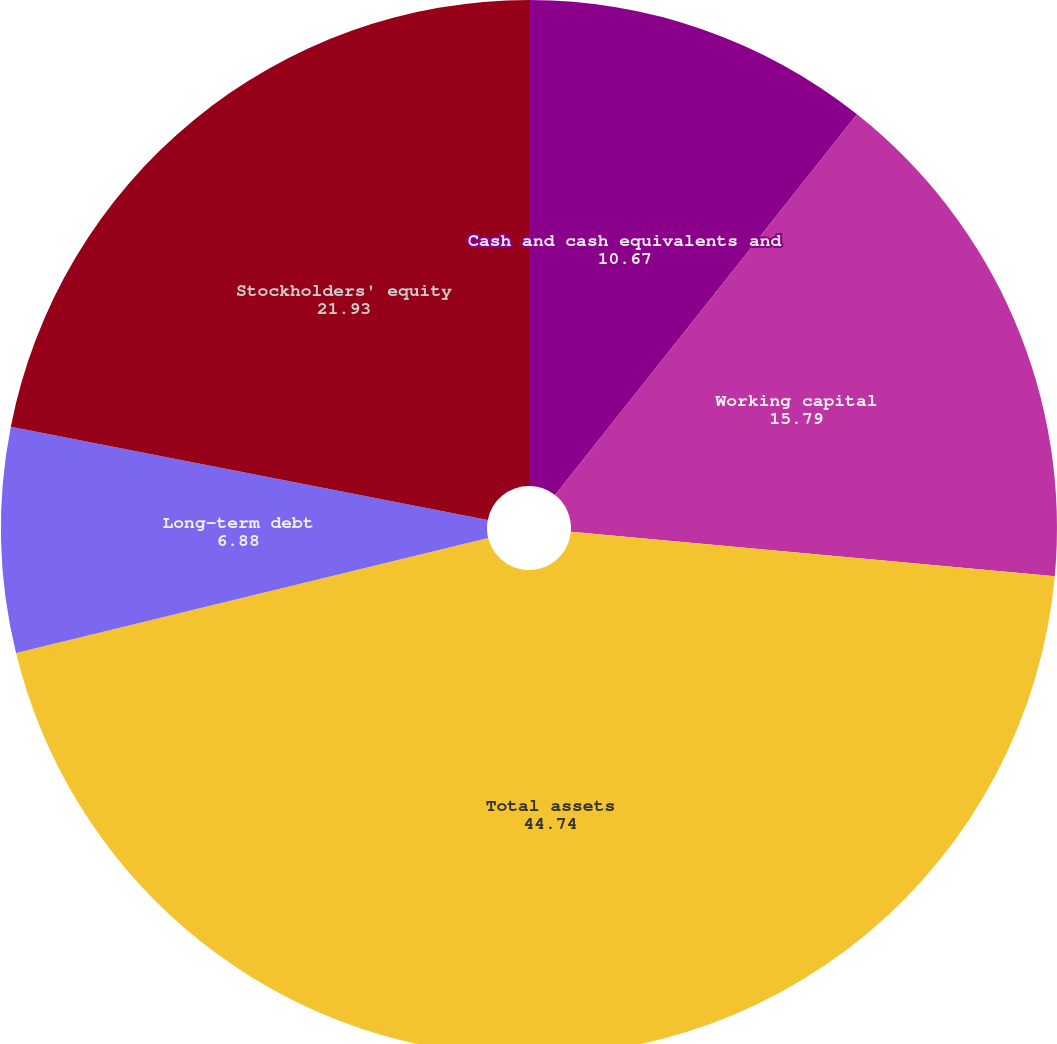<chart> <loc_0><loc_0><loc_500><loc_500><pie_chart><fcel>Cash and cash equivalents and<fcel>Working capital<fcel>Total assets<fcel>Long-term debt<fcel>Stockholders' equity<nl><fcel>10.67%<fcel>15.79%<fcel>44.74%<fcel>6.88%<fcel>21.93%<nl></chart> 